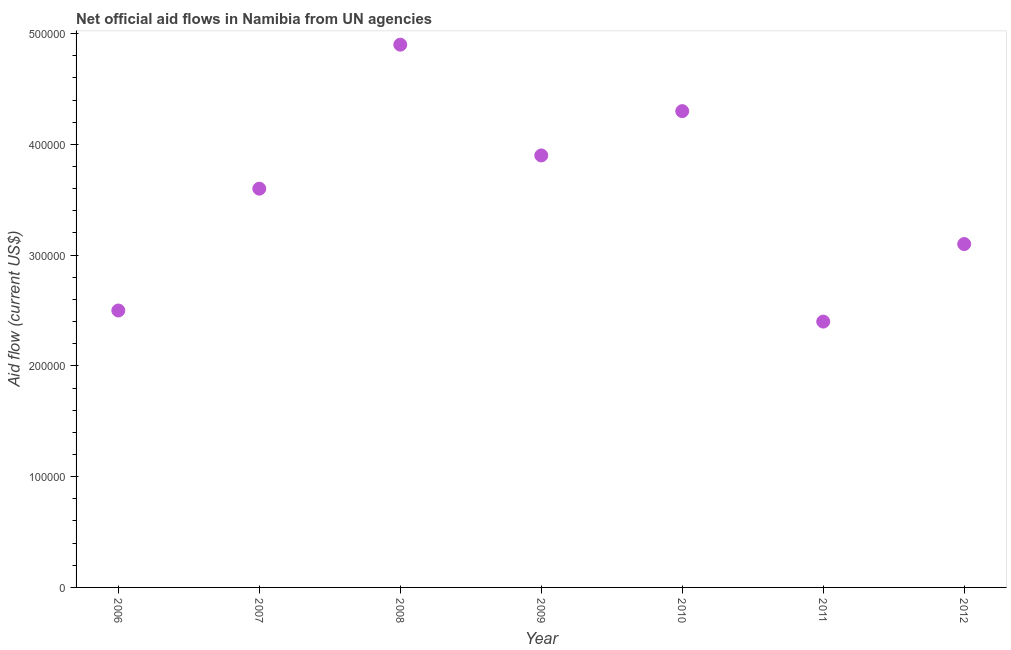What is the net official flows from un agencies in 2008?
Provide a succinct answer. 4.90e+05. Across all years, what is the maximum net official flows from un agencies?
Your answer should be very brief. 4.90e+05. Across all years, what is the minimum net official flows from un agencies?
Ensure brevity in your answer.  2.40e+05. In which year was the net official flows from un agencies maximum?
Your answer should be very brief. 2008. In which year was the net official flows from un agencies minimum?
Your answer should be compact. 2011. What is the sum of the net official flows from un agencies?
Offer a very short reply. 2.47e+06. What is the difference between the net official flows from un agencies in 2010 and 2011?
Provide a short and direct response. 1.90e+05. What is the average net official flows from un agencies per year?
Provide a short and direct response. 3.53e+05. What is the median net official flows from un agencies?
Provide a succinct answer. 3.60e+05. In how many years, is the net official flows from un agencies greater than 460000 US$?
Provide a succinct answer. 1. What is the ratio of the net official flows from un agencies in 2007 to that in 2010?
Offer a terse response. 0.84. Is the net official flows from un agencies in 2006 less than that in 2012?
Offer a terse response. Yes. Is the sum of the net official flows from un agencies in 2009 and 2011 greater than the maximum net official flows from un agencies across all years?
Keep it short and to the point. Yes. What is the difference between the highest and the lowest net official flows from un agencies?
Offer a very short reply. 2.50e+05. Are the values on the major ticks of Y-axis written in scientific E-notation?
Provide a succinct answer. No. Does the graph contain any zero values?
Give a very brief answer. No. Does the graph contain grids?
Offer a very short reply. No. What is the title of the graph?
Give a very brief answer. Net official aid flows in Namibia from UN agencies. What is the label or title of the X-axis?
Offer a very short reply. Year. What is the Aid flow (current US$) in 2007?
Provide a succinct answer. 3.60e+05. What is the Aid flow (current US$) in 2010?
Offer a terse response. 4.30e+05. What is the Aid flow (current US$) in 2011?
Offer a terse response. 2.40e+05. What is the Aid flow (current US$) in 2012?
Offer a terse response. 3.10e+05. What is the difference between the Aid flow (current US$) in 2006 and 2008?
Your answer should be compact. -2.40e+05. What is the difference between the Aid flow (current US$) in 2006 and 2009?
Keep it short and to the point. -1.40e+05. What is the difference between the Aid flow (current US$) in 2006 and 2010?
Your answer should be very brief. -1.80e+05. What is the difference between the Aid flow (current US$) in 2006 and 2012?
Give a very brief answer. -6.00e+04. What is the difference between the Aid flow (current US$) in 2007 and 2009?
Give a very brief answer. -3.00e+04. What is the difference between the Aid flow (current US$) in 2007 and 2010?
Keep it short and to the point. -7.00e+04. What is the difference between the Aid flow (current US$) in 2007 and 2012?
Your answer should be compact. 5.00e+04. What is the difference between the Aid flow (current US$) in 2008 and 2009?
Your answer should be very brief. 1.00e+05. What is the difference between the Aid flow (current US$) in 2009 and 2011?
Make the answer very short. 1.50e+05. What is the difference between the Aid flow (current US$) in 2009 and 2012?
Your answer should be very brief. 8.00e+04. What is the difference between the Aid flow (current US$) in 2010 and 2012?
Offer a very short reply. 1.20e+05. What is the ratio of the Aid flow (current US$) in 2006 to that in 2007?
Give a very brief answer. 0.69. What is the ratio of the Aid flow (current US$) in 2006 to that in 2008?
Your answer should be very brief. 0.51. What is the ratio of the Aid flow (current US$) in 2006 to that in 2009?
Your response must be concise. 0.64. What is the ratio of the Aid flow (current US$) in 2006 to that in 2010?
Keep it short and to the point. 0.58. What is the ratio of the Aid flow (current US$) in 2006 to that in 2011?
Provide a short and direct response. 1.04. What is the ratio of the Aid flow (current US$) in 2006 to that in 2012?
Ensure brevity in your answer.  0.81. What is the ratio of the Aid flow (current US$) in 2007 to that in 2008?
Provide a short and direct response. 0.73. What is the ratio of the Aid flow (current US$) in 2007 to that in 2009?
Ensure brevity in your answer.  0.92. What is the ratio of the Aid flow (current US$) in 2007 to that in 2010?
Make the answer very short. 0.84. What is the ratio of the Aid flow (current US$) in 2007 to that in 2011?
Make the answer very short. 1.5. What is the ratio of the Aid flow (current US$) in 2007 to that in 2012?
Provide a succinct answer. 1.16. What is the ratio of the Aid flow (current US$) in 2008 to that in 2009?
Give a very brief answer. 1.26. What is the ratio of the Aid flow (current US$) in 2008 to that in 2010?
Offer a terse response. 1.14. What is the ratio of the Aid flow (current US$) in 2008 to that in 2011?
Provide a succinct answer. 2.04. What is the ratio of the Aid flow (current US$) in 2008 to that in 2012?
Your answer should be very brief. 1.58. What is the ratio of the Aid flow (current US$) in 2009 to that in 2010?
Make the answer very short. 0.91. What is the ratio of the Aid flow (current US$) in 2009 to that in 2011?
Give a very brief answer. 1.62. What is the ratio of the Aid flow (current US$) in 2009 to that in 2012?
Provide a short and direct response. 1.26. What is the ratio of the Aid flow (current US$) in 2010 to that in 2011?
Give a very brief answer. 1.79. What is the ratio of the Aid flow (current US$) in 2010 to that in 2012?
Give a very brief answer. 1.39. What is the ratio of the Aid flow (current US$) in 2011 to that in 2012?
Provide a succinct answer. 0.77. 